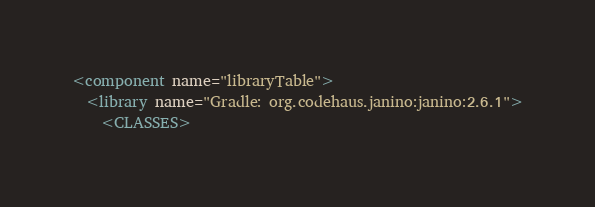<code> <loc_0><loc_0><loc_500><loc_500><_XML_><component name="libraryTable">
  <library name="Gradle: org.codehaus.janino:janino:2.6.1">
    <CLASSES></code> 